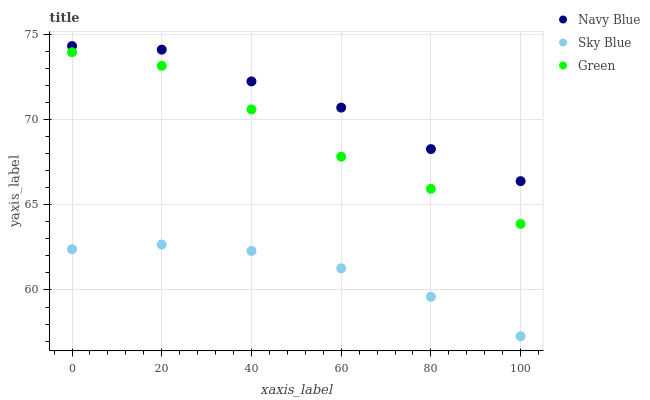Does Sky Blue have the minimum area under the curve?
Answer yes or no. Yes. Does Navy Blue have the maximum area under the curve?
Answer yes or no. Yes. Does Green have the minimum area under the curve?
Answer yes or no. No. Does Green have the maximum area under the curve?
Answer yes or no. No. Is Sky Blue the smoothest?
Answer yes or no. Yes. Is Navy Blue the roughest?
Answer yes or no. Yes. Is Green the smoothest?
Answer yes or no. No. Is Green the roughest?
Answer yes or no. No. Does Sky Blue have the lowest value?
Answer yes or no. Yes. Does Green have the lowest value?
Answer yes or no. No. Does Navy Blue have the highest value?
Answer yes or no. Yes. Does Green have the highest value?
Answer yes or no. No. Is Sky Blue less than Green?
Answer yes or no. Yes. Is Navy Blue greater than Sky Blue?
Answer yes or no. Yes. Does Sky Blue intersect Green?
Answer yes or no. No. 